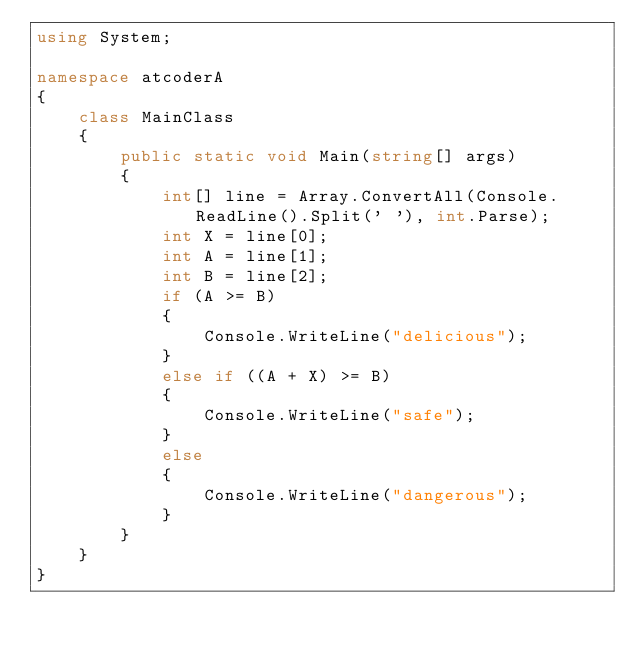<code> <loc_0><loc_0><loc_500><loc_500><_C#_>using System;

namespace atcoderA
{
    class MainClass
    {
        public static void Main(string[] args)
        {
            int[] line = Array.ConvertAll(Console.ReadLine().Split(' '), int.Parse);
            int X = line[0];
            int A = line[1];
            int B = line[2];
            if (A >= B)
            {
                Console.WriteLine("delicious");
            }
            else if ((A + X) >= B)
            {
                Console.WriteLine("safe");
            }
            else
            {
                Console.WriteLine("dangerous");
            }
        }
    }
}</code> 